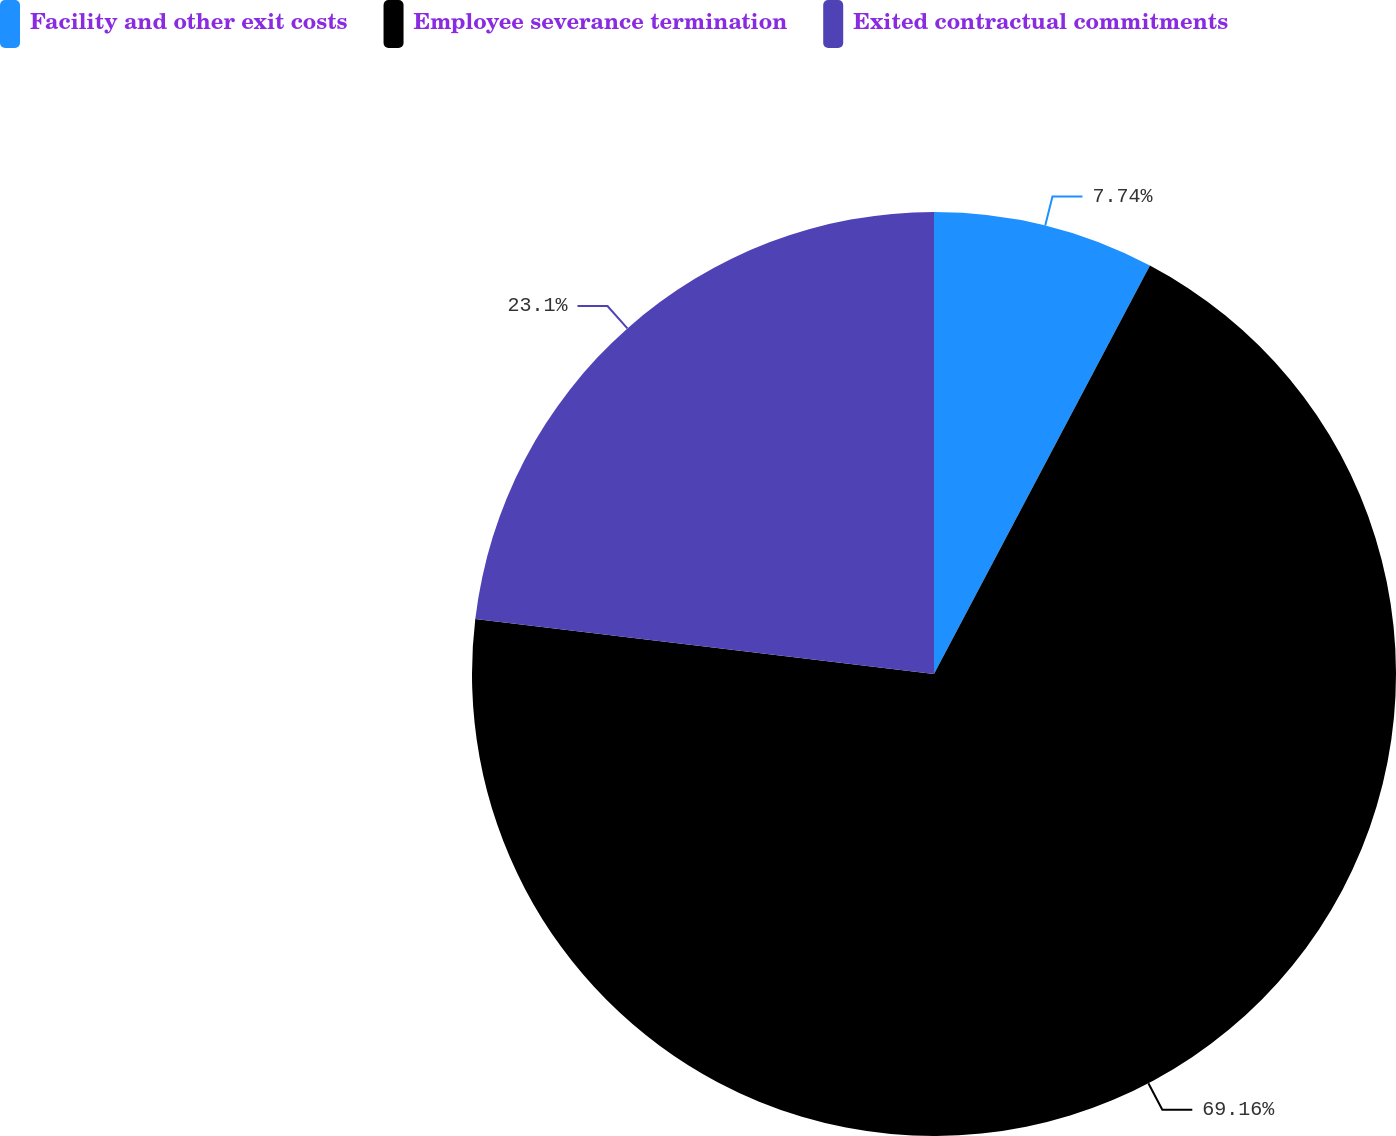Convert chart. <chart><loc_0><loc_0><loc_500><loc_500><pie_chart><fcel>Facility and other exit costs<fcel>Employee severance termination<fcel>Exited contractual commitments<nl><fcel>7.74%<fcel>69.16%<fcel>23.1%<nl></chart> 